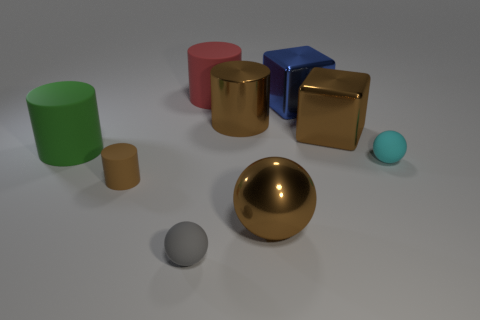Is the material of the small gray sphere the same as the large object in front of the brown rubber thing?
Your answer should be compact. No. The big thing that is in front of the matte sphere on the right side of the red cylinder is what shape?
Your answer should be compact. Sphere. What is the shape of the small object that is both on the left side of the large red matte cylinder and behind the gray ball?
Give a very brief answer. Cylinder. What number of things are large metallic balls or large blocks in front of the brown shiny cylinder?
Give a very brief answer. 2. There is a small brown thing that is the same shape as the green rubber object; what material is it?
Offer a very short reply. Rubber. Is there any other thing that has the same material as the large brown cylinder?
Provide a short and direct response. Yes. What material is the ball that is both on the right side of the big red object and in front of the tiny brown cylinder?
Make the answer very short. Metal. How many large red metallic things are the same shape as the small gray rubber object?
Offer a very short reply. 0. There is a small rubber ball in front of the matte cylinder in front of the cyan rubber thing; what color is it?
Give a very brief answer. Gray. Is the number of big cylinders in front of the small cylinder the same as the number of large green metallic objects?
Your answer should be very brief. Yes. 